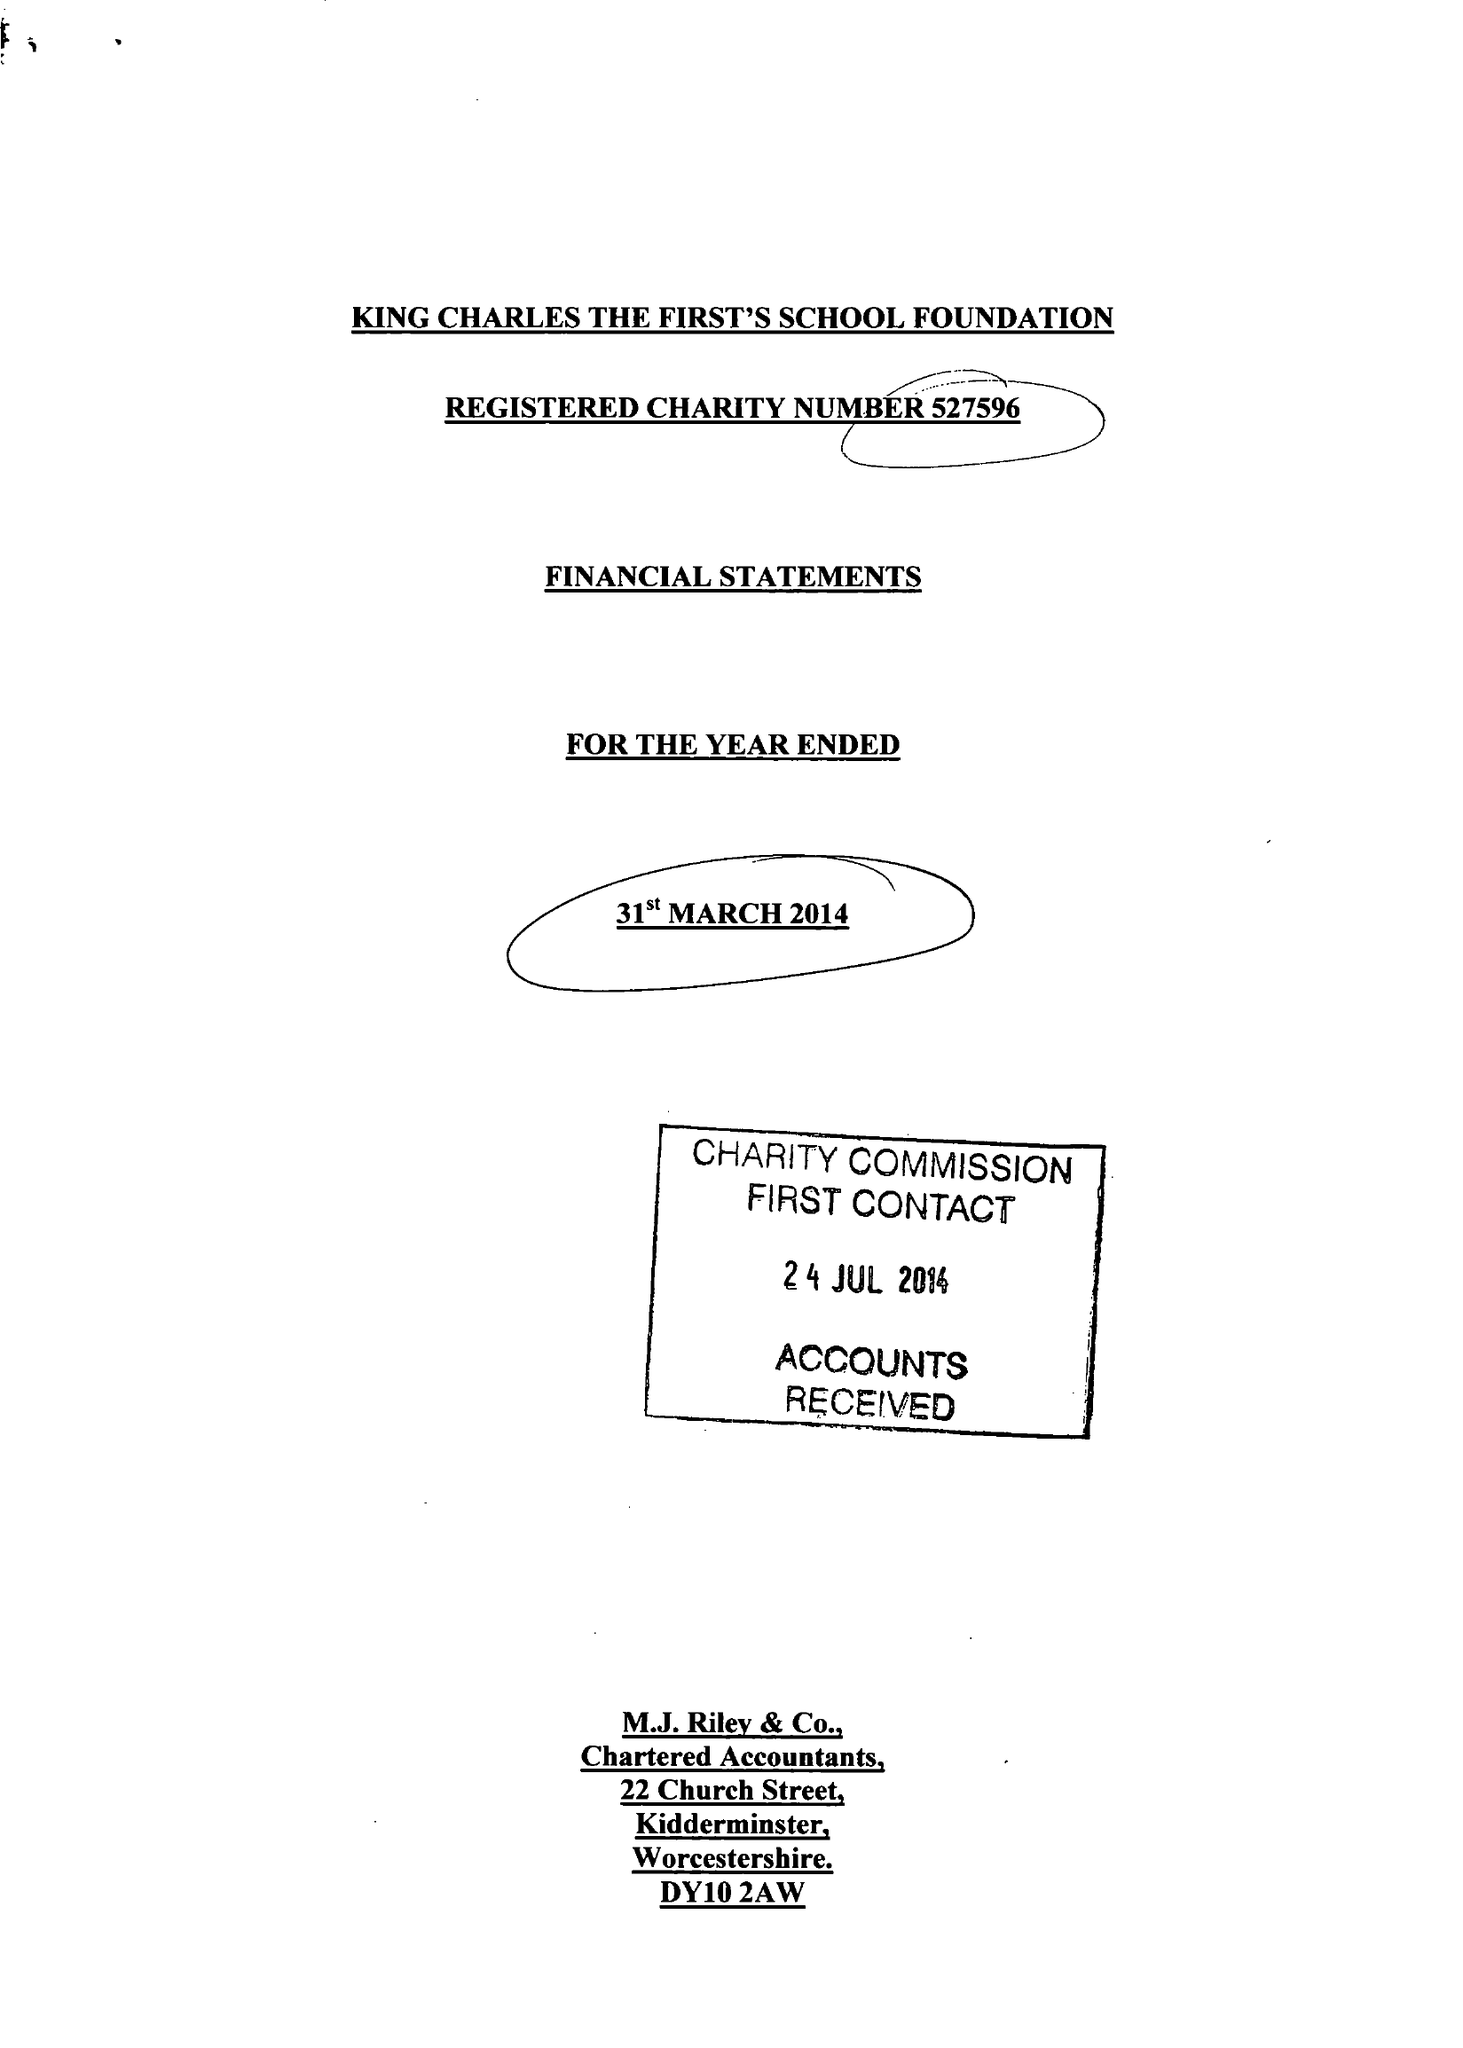What is the value for the address__postcode?
Answer the question using a single word or phrase. DY13 9JF 